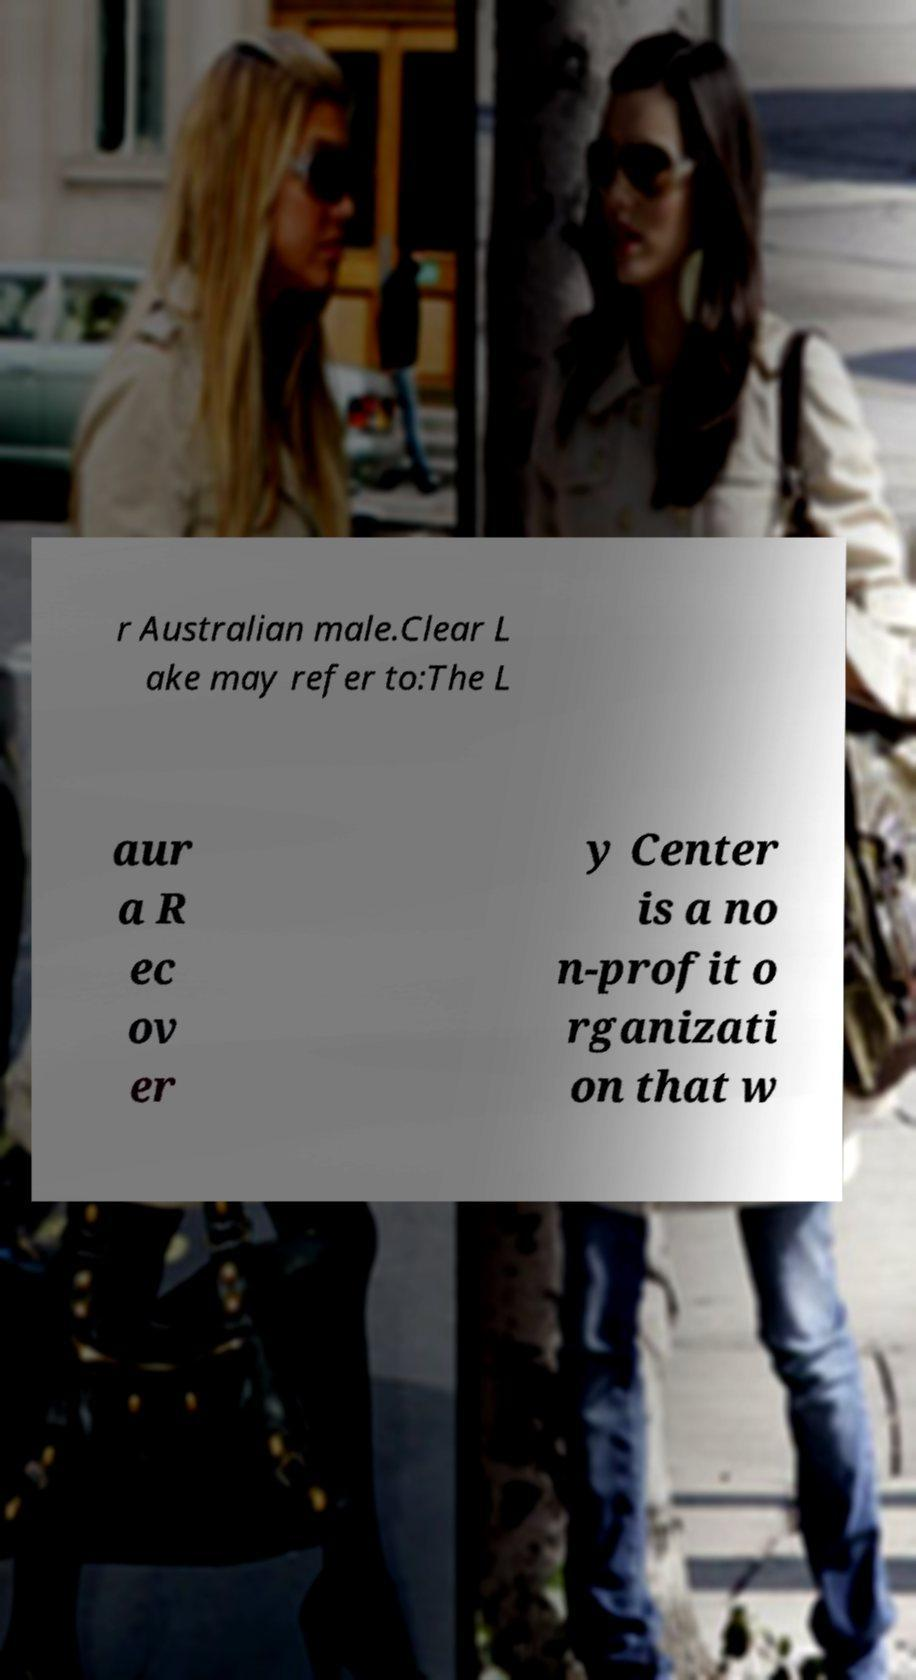Please identify and transcribe the text found in this image. r Australian male.Clear L ake may refer to:The L aur a R ec ov er y Center is a no n-profit o rganizati on that w 